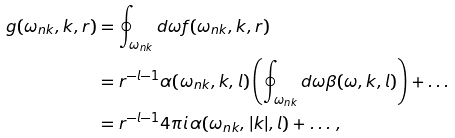Convert formula to latex. <formula><loc_0><loc_0><loc_500><loc_500>g ( \omega _ { n k } , k , r ) & = \oint _ { \omega _ { n k } } d \omega f ( \omega _ { n k } , k , r ) \\ & = r ^ { - l - 1 } \alpha ( \omega _ { n k } , k , l ) \left ( \oint _ { \omega _ { n k } } d \omega \beta ( \omega , k , l ) \right ) + \dots \\ & = r ^ { - l - 1 } 4 \pi i \, \alpha ( \omega _ { n k } , | k | , l ) + \dots \, ,</formula> 